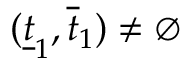<formula> <loc_0><loc_0><loc_500><loc_500>( \underline { t } _ { 1 } , \overline { t } _ { 1 } ) \not = \emptyset</formula> 